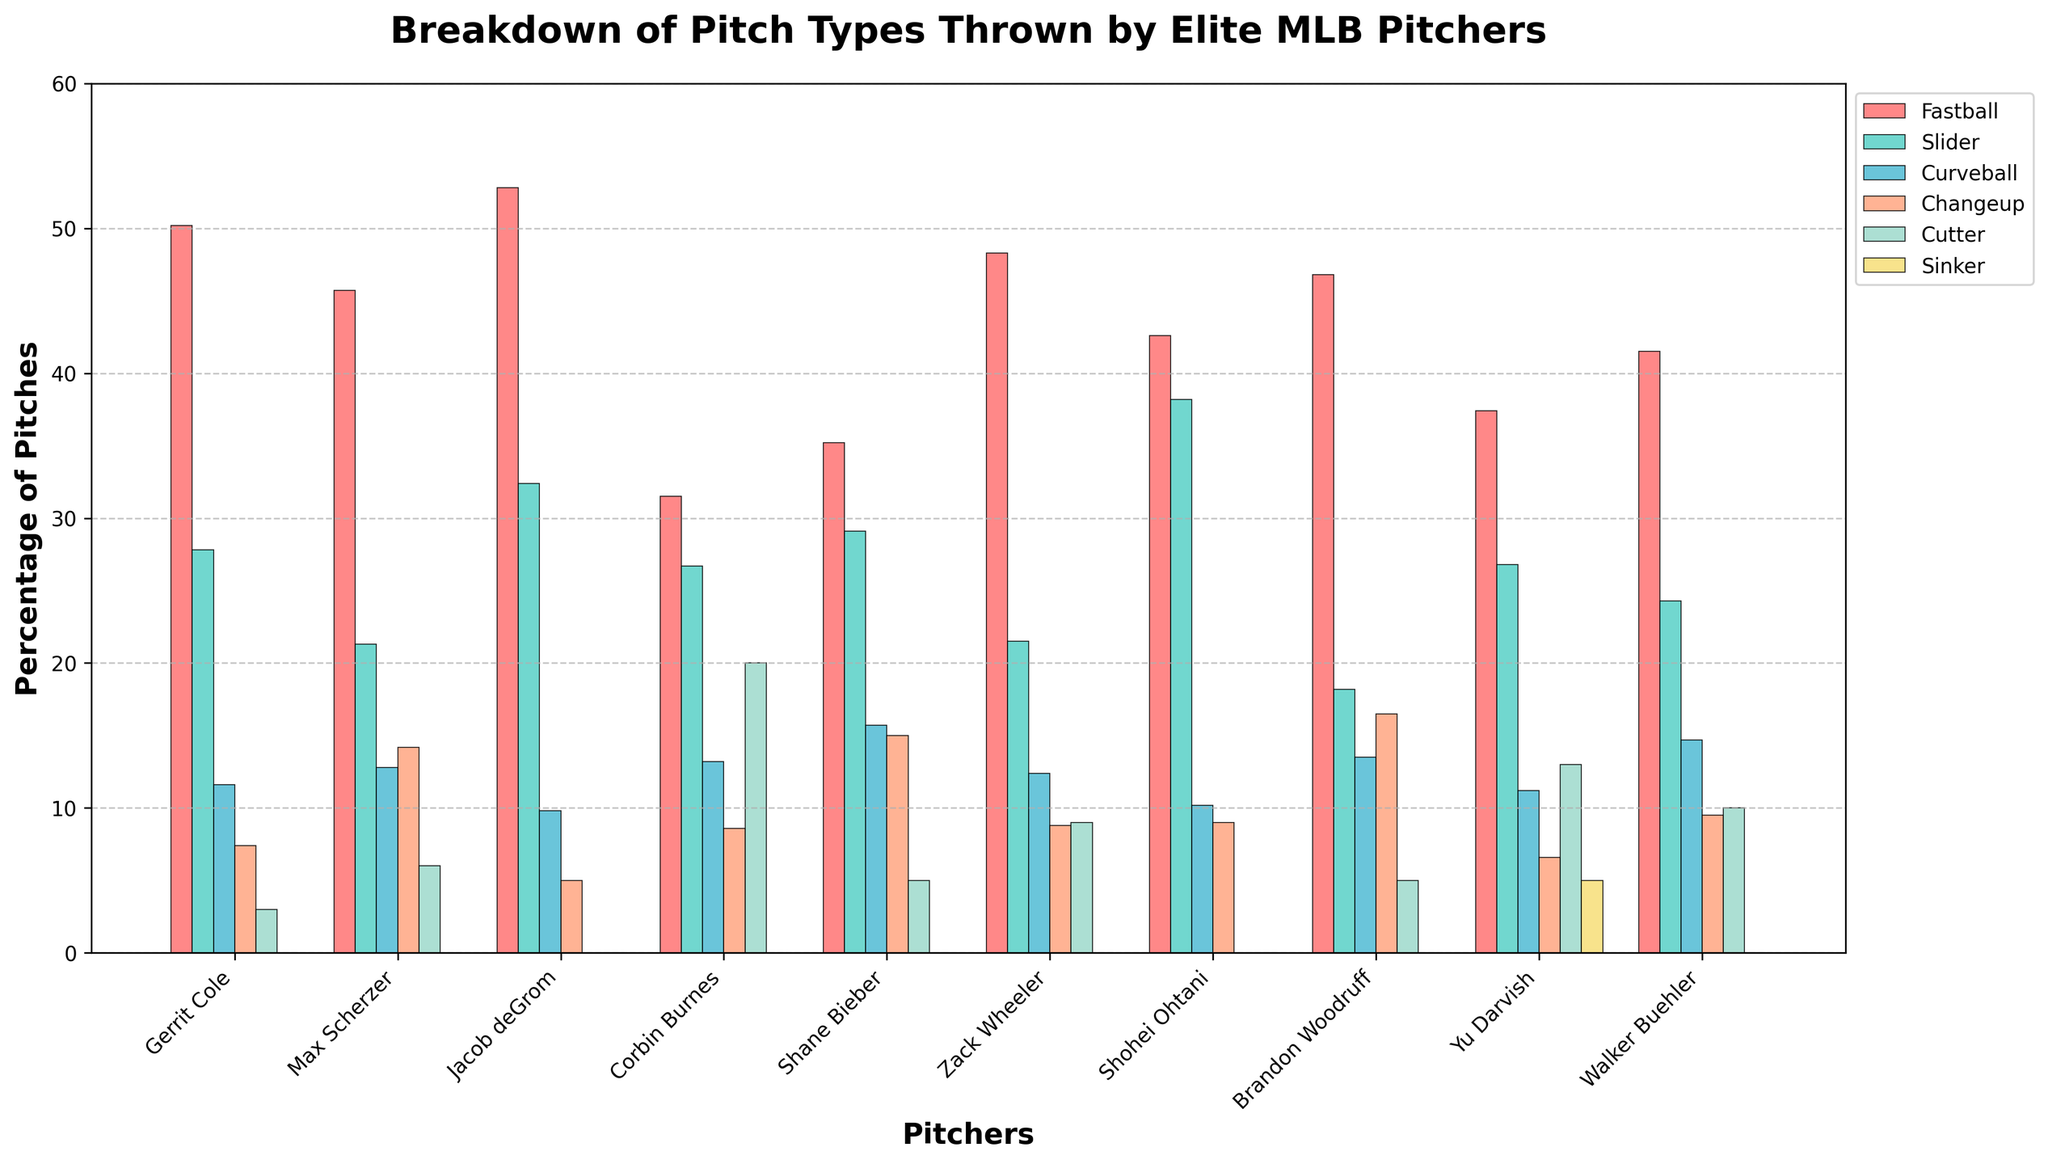Which pitcher throws the highest percentage of fastballs? By examining the heights of the bars corresponding to fastballs, Jacob deGrom's bar is the tallest, indicating he throws the highest percentage of fastballs.
Answer: Jacob deGrom Who throws more sliders, Shohei Ohtani or Gerrit Cole? Comparing the slider bars, Shohei Ohtani has a taller bar than Gerrit Cole, which means Ohtani throws more sliders.
Answer: Shohei Ohtani What is the total percentage of pitches thrown by Zack Wheeler for fastballs and changeups combined? Sum the heights of Zack Wheeler's fastball bar (48.3) and changeup bar (8.8). 48.3 + 8.8 equals 57.1.
Answer: 57.1 Which pitch type is used least by Max Scherzer? Observing the heights of the bars for Max Scherzer, the cutter has the smallest bar height among all pitch types.
Answer: Cutter Compare the percentage of curveballs thrown by Shane Bieber and Walker Buehler. Who throws more and by how much? Shane Bieber's curveball bar shows 15.7%, while Walker Buehler's shows 14.7%. Subtracting 14.7 from 15.7 gives 1.0.
Answer: Shane Bieber, 1.0 For Yu Darvish, what is the difference in the percentage of cutters and sinkers thrown? Yu Darvish's cutter bar is 13.0%, and his sinker bar is 5.0%. Subtracting 5.0 from 13.0 gives 8.0.
Answer: 8.0 Which pitcher appears to have the most balanced distribution of pitch types? Observing the heights of the bars across all pitch types to identify a pitcher with relatively uniform bar heights, Yu Darvish's distribution of bars is more balanced compared to the others.
Answer: Yu Darvish Identify the pitchers who throw no sinkers. All bars for sinkers with height 0. By examining, pitchers with no bar height for sinkers are Gerrit Cole, Max Scherzer, Jacob deGrom, Corbin Burnes, Shane Bieber, Zack Wheeler, Shohei Ohtani, Brandon Woodruff, and Walker Buehler.
Answer: 9 pitchers What's the average percentage of curveballs thrown by all pitchers? Sum up the percentages for curveballs for each pitcher (11.6, 12.8, 9.8, 13.2, 15.7, 12.4, 10.2, 13.5, 11.2, 14.7) which equals 125.1 and then divide by the number of pitchers (10). 125.1 / 10 = 12.51.
Answer: 12.51 Which pitcher has the highest percentage of sliders, and what is that percentage? Identifying the tallest bar for sliders, Shohei Ohtani has the tallest bar at 38.2%.
Answer: Shohei Ohtani, 38.2 